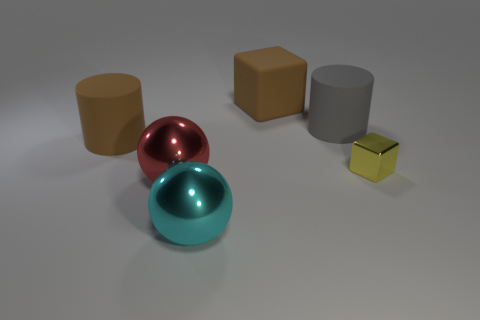Add 4 large brown rubber cylinders. How many objects exist? 10 Subtract all cubes. How many objects are left? 4 Subtract all brown rubber blocks. Subtract all big metallic balls. How many objects are left? 3 Add 2 cyan metal spheres. How many cyan metal spheres are left? 3 Add 4 big red shiny spheres. How many big red shiny spheres exist? 5 Subtract 0 purple blocks. How many objects are left? 6 